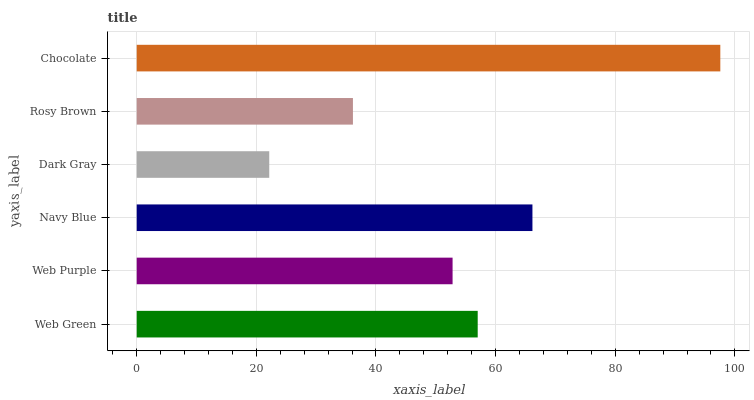Is Dark Gray the minimum?
Answer yes or no. Yes. Is Chocolate the maximum?
Answer yes or no. Yes. Is Web Purple the minimum?
Answer yes or no. No. Is Web Purple the maximum?
Answer yes or no. No. Is Web Green greater than Web Purple?
Answer yes or no. Yes. Is Web Purple less than Web Green?
Answer yes or no. Yes. Is Web Purple greater than Web Green?
Answer yes or no. No. Is Web Green less than Web Purple?
Answer yes or no. No. Is Web Green the high median?
Answer yes or no. Yes. Is Web Purple the low median?
Answer yes or no. Yes. Is Navy Blue the high median?
Answer yes or no. No. Is Rosy Brown the low median?
Answer yes or no. No. 